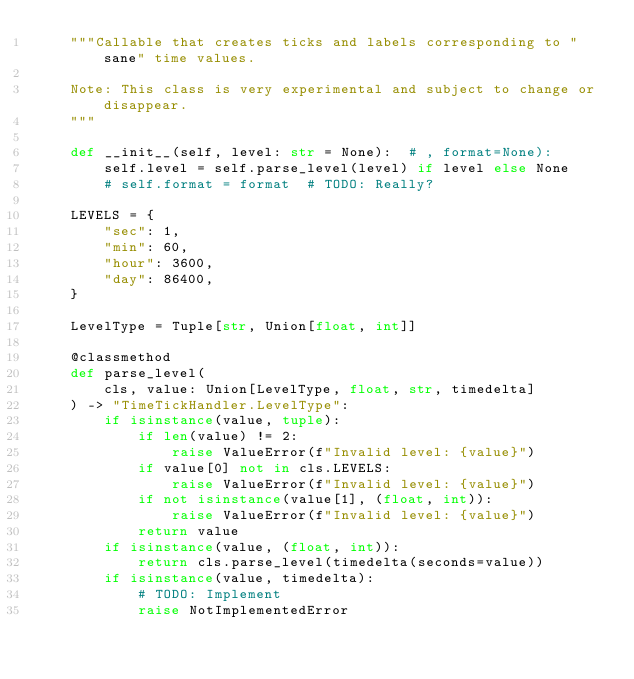Convert code to text. <code><loc_0><loc_0><loc_500><loc_500><_Python_>    """Callable that creates ticks and labels corresponding to "sane" time values.

    Note: This class is very experimental and subject to change or disappear.
    """

    def __init__(self, level: str = None):  # , format=None):
        self.level = self.parse_level(level) if level else None
        # self.format = format  # TODO: Really?

    LEVELS = {
        "sec": 1,
        "min": 60,
        "hour": 3600,
        "day": 86400,
    }

    LevelType = Tuple[str, Union[float, int]]

    @classmethod
    def parse_level(
        cls, value: Union[LevelType, float, str, timedelta]
    ) -> "TimeTickHandler.LevelType":
        if isinstance(value, tuple):
            if len(value) != 2:
                raise ValueError(f"Invalid level: {value}")
            if value[0] not in cls.LEVELS:
                raise ValueError(f"Invalid level: {value}")
            if not isinstance(value[1], (float, int)):
                raise ValueError(f"Invalid level: {value}")
            return value
        if isinstance(value, (float, int)):
            return cls.parse_level(timedelta(seconds=value))
        if isinstance(value, timedelta):
            # TODO: Implement
            raise NotImplementedError</code> 